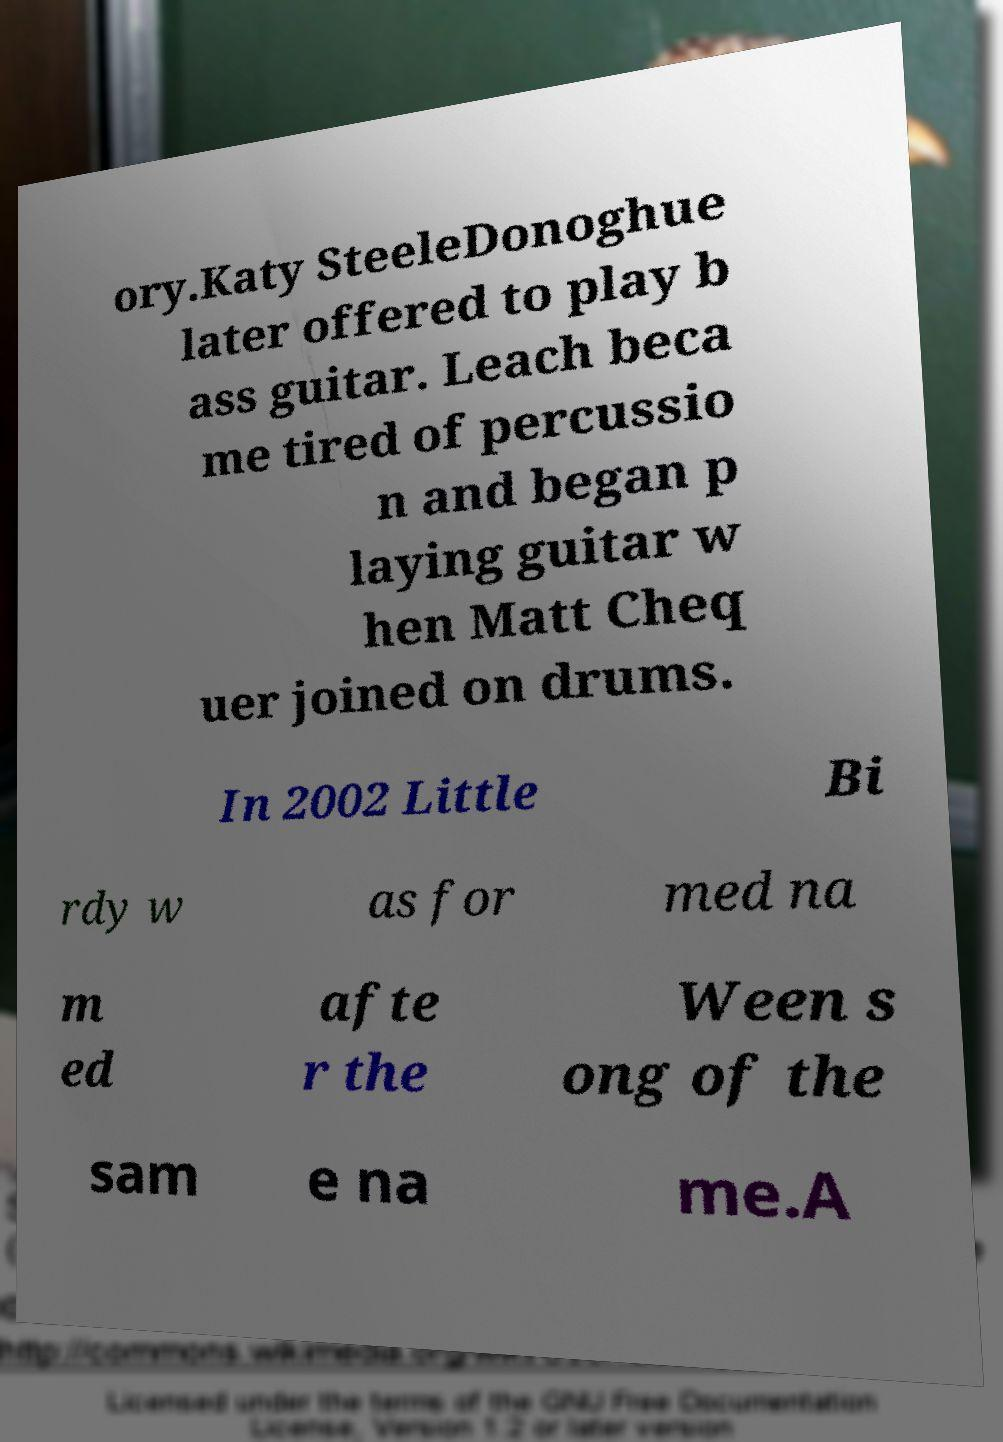Please identify and transcribe the text found in this image. ory.Katy SteeleDonoghue later offered to play b ass guitar. Leach beca me tired of percussio n and began p laying guitar w hen Matt Cheq uer joined on drums. In 2002 Little Bi rdy w as for med na m ed afte r the Ween s ong of the sam e na me.A 